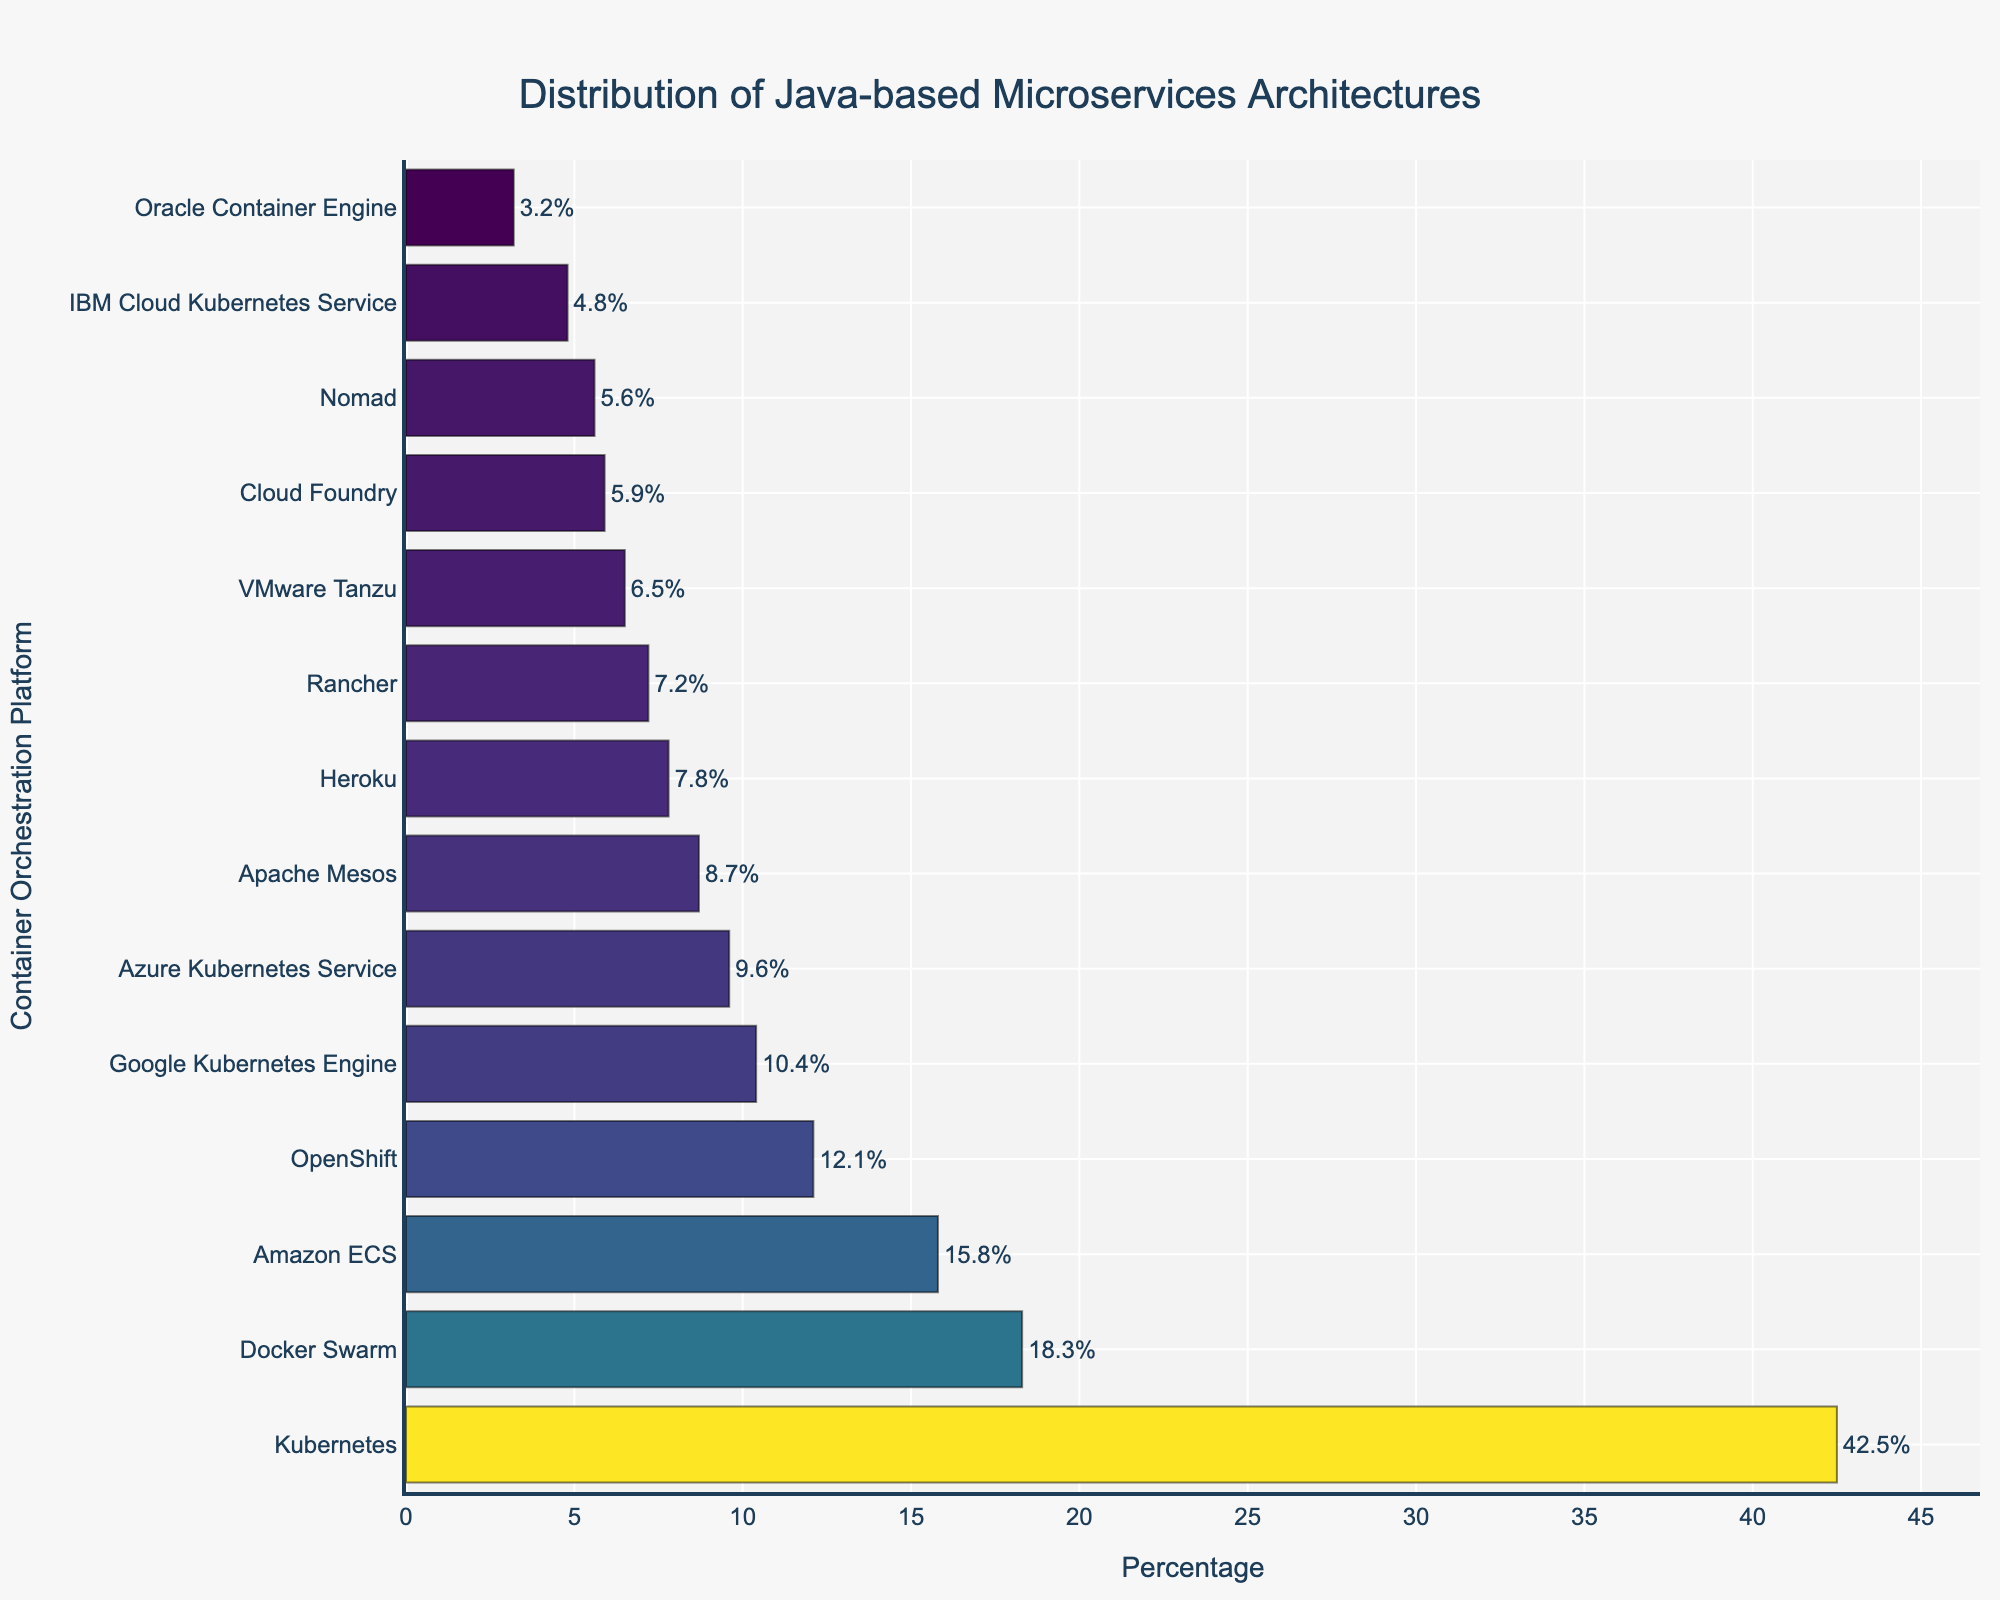Which platform has the highest percentage of Java-based microservices architectures? The platform with the longest bar represents the highest percentage. According to the figure, Kubernetes has the longest bar, indicating the highest percentage.
Answer: Kubernetes Which platform shows the lowest percentage of Java-based microservices architectures? The platform with the shortest bar represents the lowest percentage. According to the figure, Oracle Container Engine has the shortest bar, indicating the lowest percentage.
Answer: Oracle Container Engine How does the percentage of Amazon ECS compare to that of Google Kubernetes Engine? To compare the percentages, look at the lengths of the bars for Amazon ECS and Google Kubernetes Engine. According to the figure, Amazon ECS has a higher percentage (15.8%) compared to Google Kubernetes Engine (10.4%).
Answer: Amazon ECS is higher What is the combined percentage of microservices architectures on Kubernetes and Docker Swarm? Add the percentages of Kubernetes (42.5%) and Docker Swarm (18.3%). 42.5 + 18.3 = 60.8.
Answer: 60.8% Which three platforms have percentages closest to 10%? Identify the bars with percentages near 10%. The platforms are Google Kubernetes Engine (10.4%), Azure Kubernetes Service (9.6%), and OpenShift (12.1%), with OpenShift being slightly above 10%.
Answer: Google Kubernetes Engine, Azure Kubernetes Service, and OpenShift What is the percentage difference between IBM Cloud Kubernetes Service and Heroku? Subtract the percentage of IBM Cloud Kubernetes Service (4.8%) from that of Heroku (7.8%). 7.8 - 4.8 = 3.0.
Answer: 3.0% What is the average percentage of the platforms that have more than 10% usage? Identify platforms with percentages greater than 10%: Kubernetes (42.5%), Docker Swarm (18.3%), OpenShift (12.1%), and Amazon ECS (15.8%). Calculate the average: (42.5 + 18.3 + 12.1 + 15.8) / 4 = 22.175.
Answer: 22.2% How many platforms have a percentage greater than 5% but less than 10%? Count the platforms with percentages between 5% and 10%. The platforms are Apache Mesos (8.7%), Rancher (7.2%), Google Kubernetes Engine (10.4%), Azure Kubernetes Service (9.6%), IBM Cloud Kubernetes Service (4.8%), Cloud Foundry (5.9%), and Heroku (7.8%). However, Google Kubernetes Engine and Azure Kubernetes Service are slightly above 10%. Therefore, the platforms within the range are Apache Mesos, Rancher, Cloud Foundry, and Heroku, so there are 4 platforms.
Answer: 4 Is VMware Tanzu's percentage higher than Nomad's percentage? Compare the percentage bars for VMware Tanzu (6.5%) and Nomad (5.6%). According to the figure, VMware Tanzu's percentage is higher than Nomad's.
Answer: Yes Which two platforms have the most similar usage percentages? Look for two bars that have close lengths. Cloud Foundry (5.9%) and Nomad (5.6%) have the most similar usage percentages. The difference is 5.9 - 5.6 = 0.3.
Answer: Cloud Foundry and Nomad 